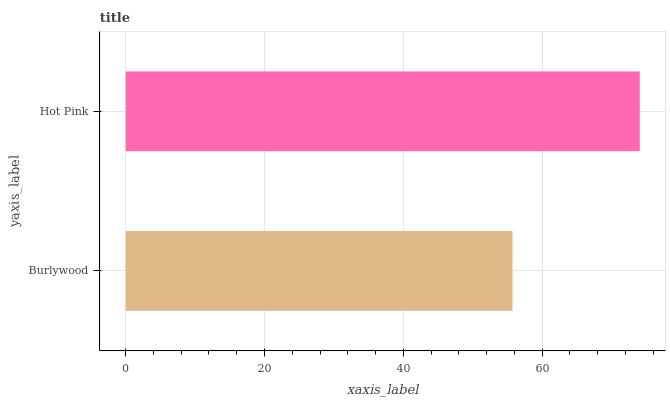Is Burlywood the minimum?
Answer yes or no. Yes. Is Hot Pink the maximum?
Answer yes or no. Yes. Is Hot Pink the minimum?
Answer yes or no. No. Is Hot Pink greater than Burlywood?
Answer yes or no. Yes. Is Burlywood less than Hot Pink?
Answer yes or no. Yes. Is Burlywood greater than Hot Pink?
Answer yes or no. No. Is Hot Pink less than Burlywood?
Answer yes or no. No. Is Hot Pink the high median?
Answer yes or no. Yes. Is Burlywood the low median?
Answer yes or no. Yes. Is Burlywood the high median?
Answer yes or no. No. Is Hot Pink the low median?
Answer yes or no. No. 